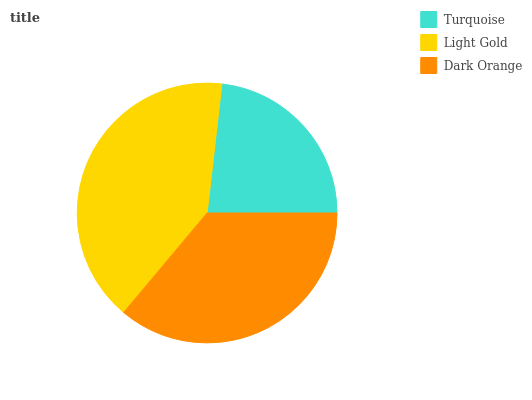Is Turquoise the minimum?
Answer yes or no. Yes. Is Light Gold the maximum?
Answer yes or no. Yes. Is Dark Orange the minimum?
Answer yes or no. No. Is Dark Orange the maximum?
Answer yes or no. No. Is Light Gold greater than Dark Orange?
Answer yes or no. Yes. Is Dark Orange less than Light Gold?
Answer yes or no. Yes. Is Dark Orange greater than Light Gold?
Answer yes or no. No. Is Light Gold less than Dark Orange?
Answer yes or no. No. Is Dark Orange the high median?
Answer yes or no. Yes. Is Dark Orange the low median?
Answer yes or no. Yes. Is Light Gold the high median?
Answer yes or no. No. Is Turquoise the low median?
Answer yes or no. No. 